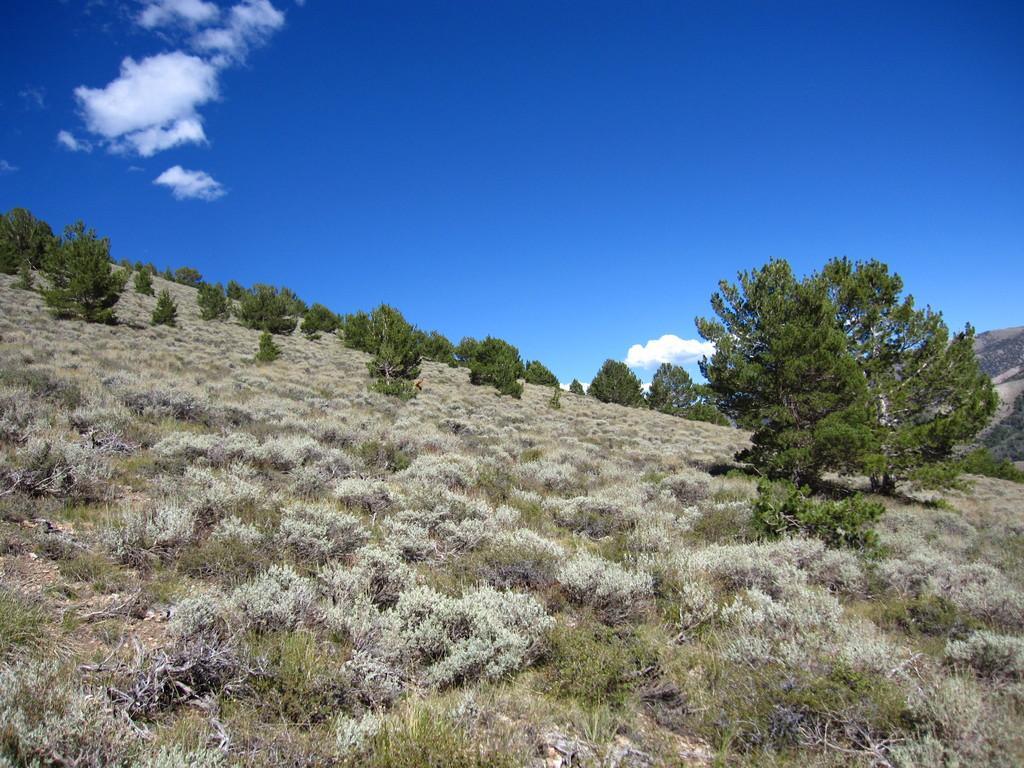Could you give a brief overview of what you see in this image? In the picture we can see a hill surface on it, we can see, full of grass plants and some plants and tree and in the background we can see a sky with clouds. 